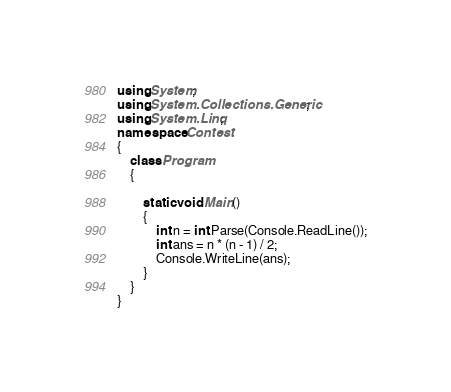<code> <loc_0><loc_0><loc_500><loc_500><_C#_>using System;
using System.Collections.Generic;
using System.Linq;
namespace Contest
{
    class Program
    {

        static void Main()
        {
            int n = int.Parse(Console.ReadLine());
            int ans = n * (n - 1) / 2;
            Console.WriteLine(ans);
        }
    }
}
</code> 